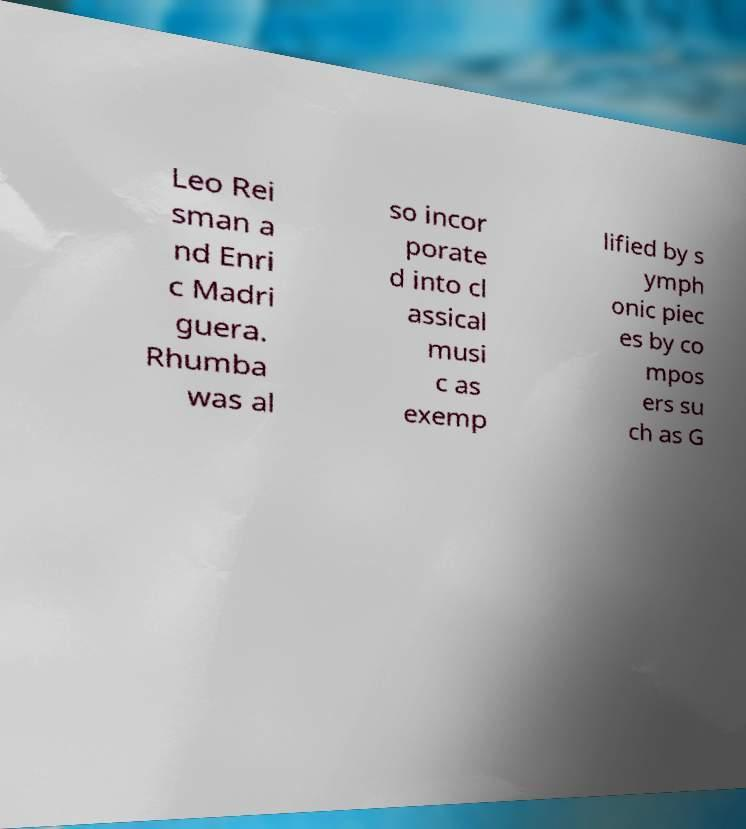Could you assist in decoding the text presented in this image and type it out clearly? Leo Rei sman a nd Enri c Madri guera. Rhumba was al so incor porate d into cl assical musi c as exemp lified by s ymph onic piec es by co mpos ers su ch as G 